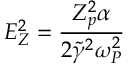<formula> <loc_0><loc_0><loc_500><loc_500>E _ { Z } ^ { 2 } = \frac { Z _ { p } ^ { 2 } \alpha } { 2 \tilde { \gamma } ^ { 2 } \omega _ { P } ^ { 2 } }</formula> 